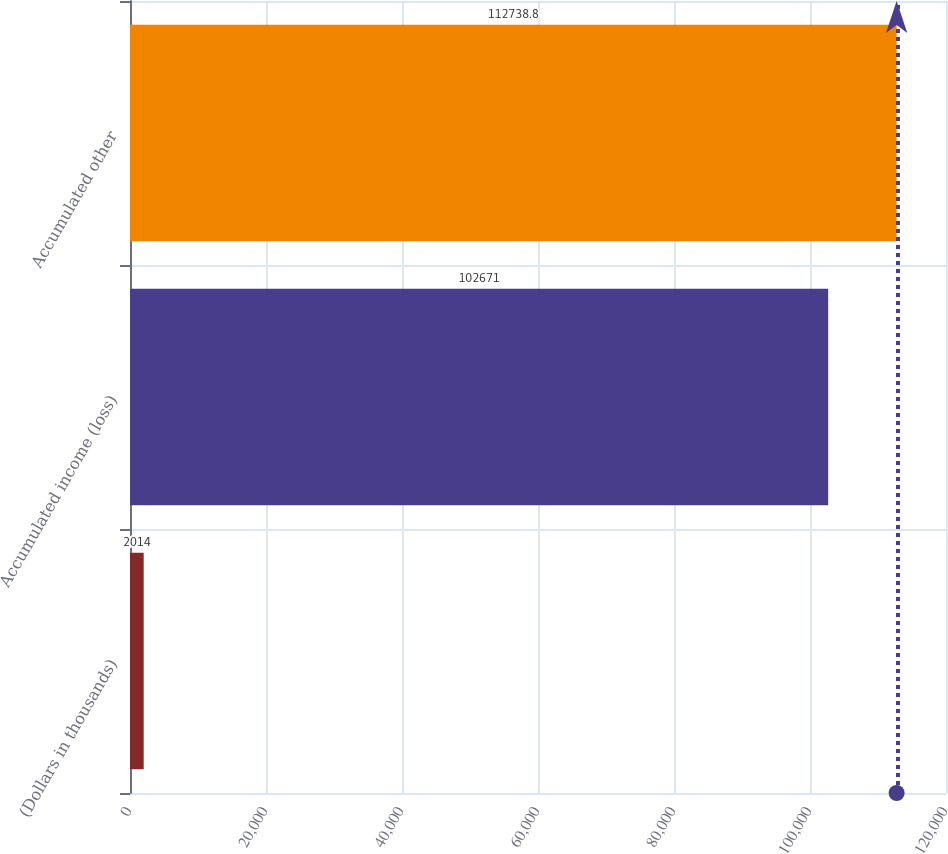Convert chart. <chart><loc_0><loc_0><loc_500><loc_500><bar_chart><fcel>(Dollars in thousands)<fcel>Accumulated income (loss)<fcel>Accumulated other<nl><fcel>2014<fcel>102671<fcel>112739<nl></chart> 